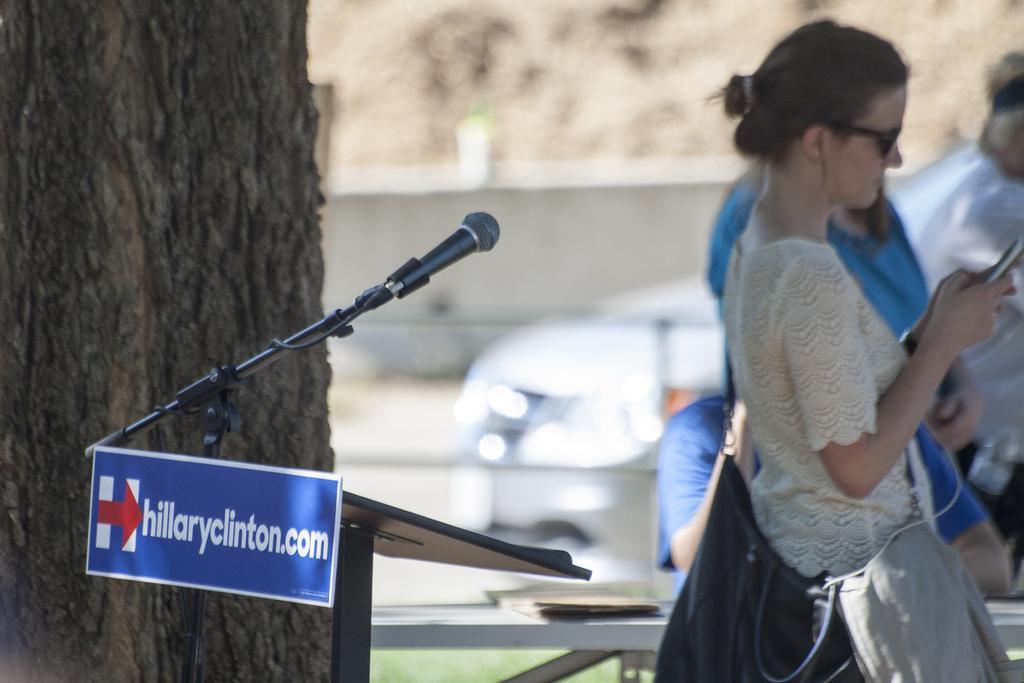Describe this image in one or two sentences. In this picture we can see about a girl wearing white top, standing and seeing in the phone. Beside we can see another girl is standing and looking to her. In front we can see black speech desk with microphone attached to it. Behind we can see tree branch. 